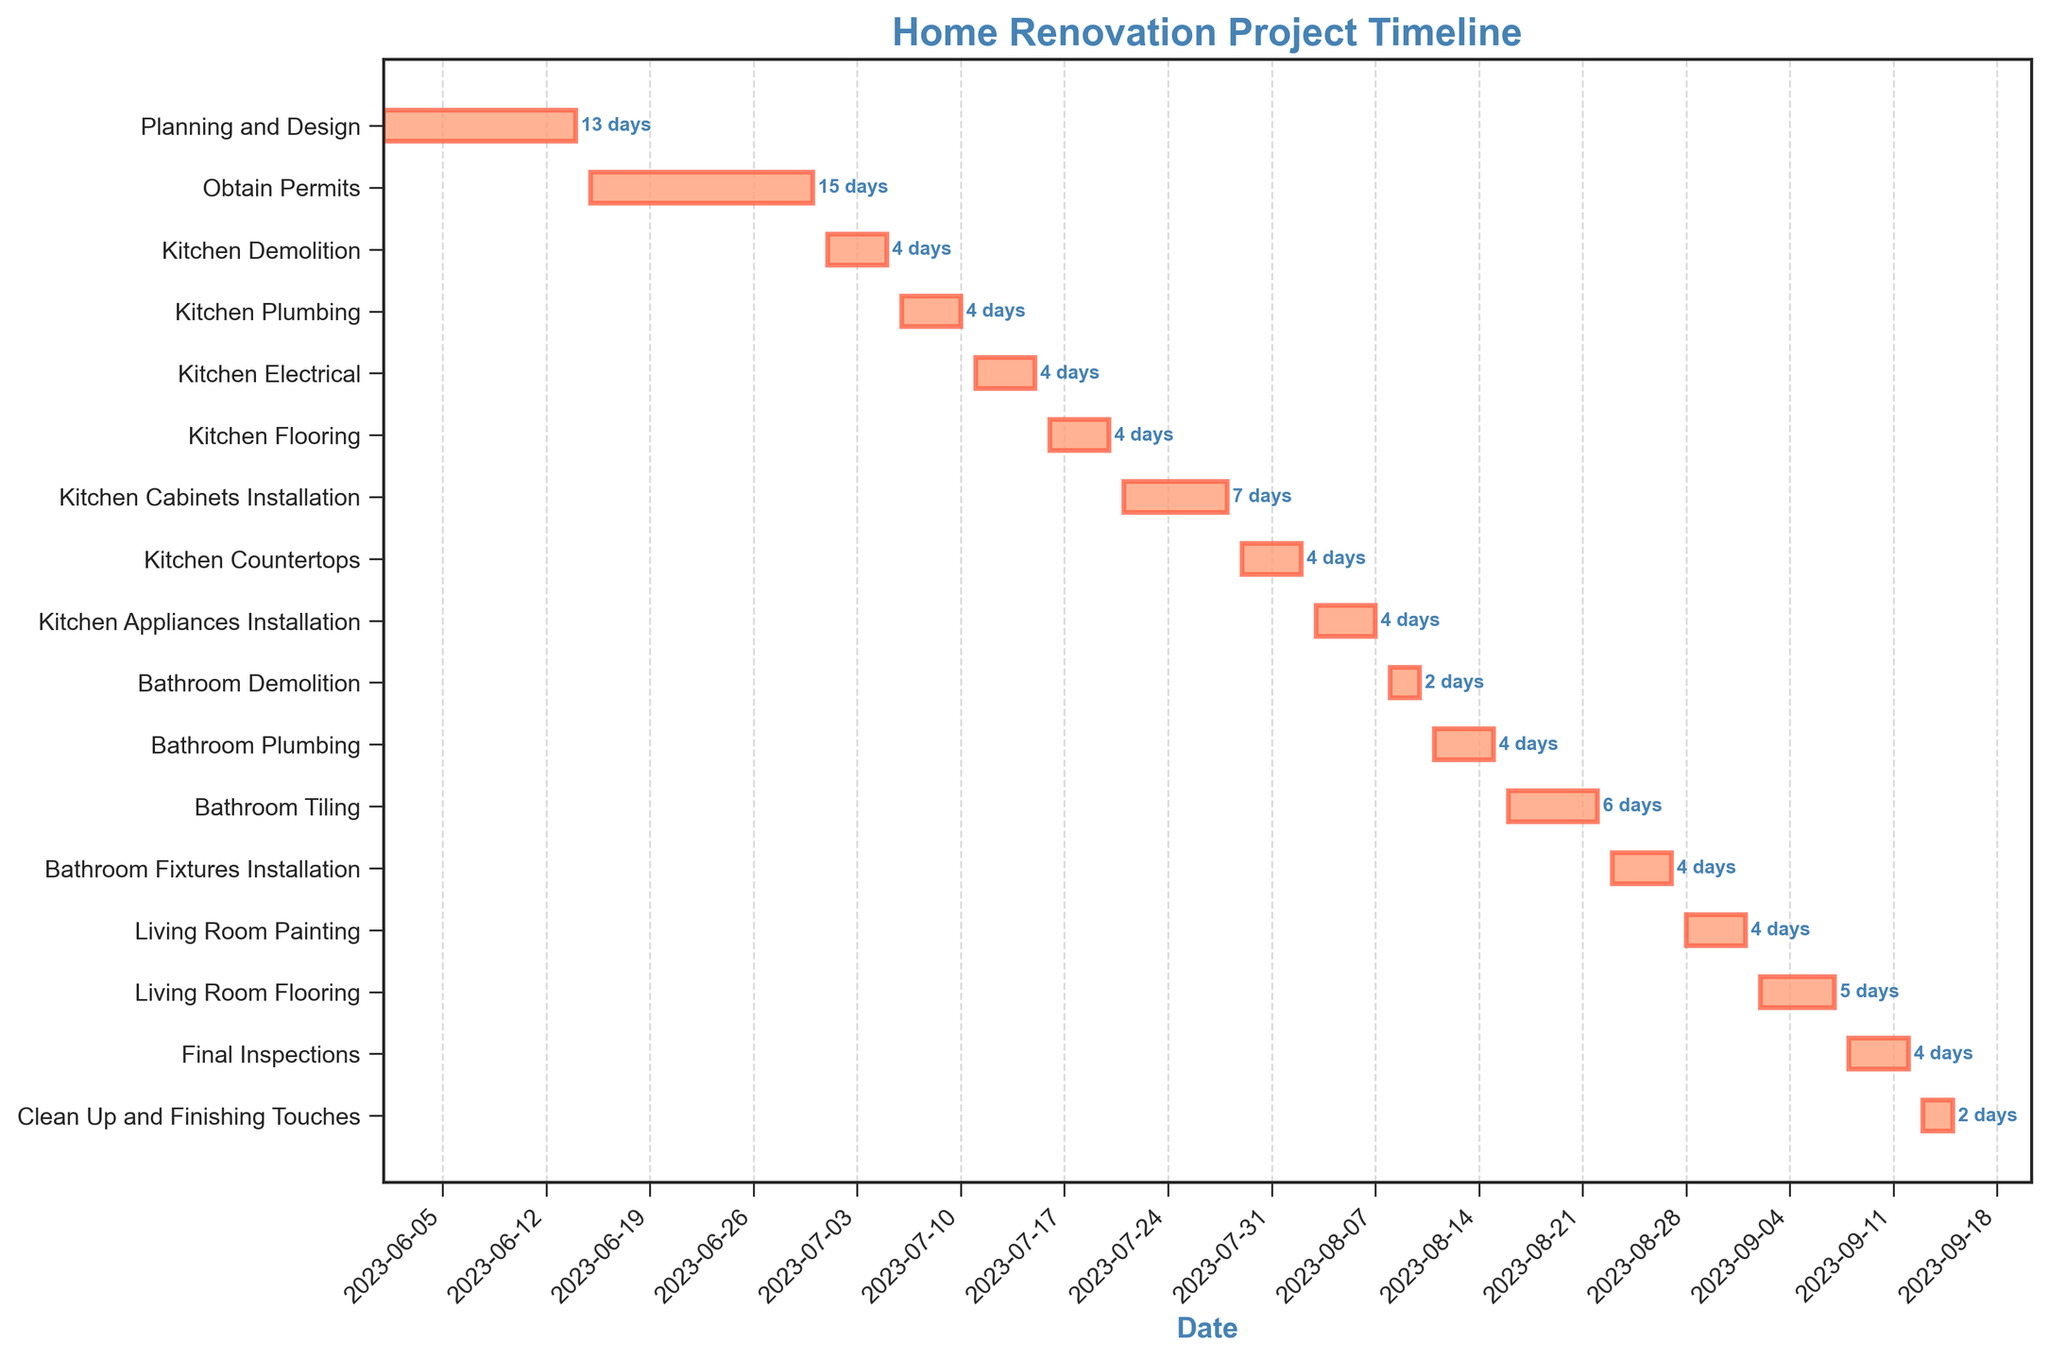What is the title of the figure? The title of the figure is displayed at the top and reads "Home Renovation Project Timeline."
Answer: Home Renovation Project Timeline When does the "Kitchen Plumbing" task start and end? The "Kitchen Plumbing" task starts on July 6, 2023, and ends on July 10, 2023, as indicated by the horizontal bar's start and end points on the y-axis.
Answer: July 6, 2023, to July 10, 2023 Which task takes the longest time to complete, and how many days does it take? By examining the lengths of all the horizontal bars, the "Bathroom Tiling" task takes the longest to complete, spanning from August 16 to August 22, which is 7 days.
Answer: Bathroom Tiling, 7 days How many tasks are scheduled to occur during August? By observing the timeline, the tasks are: "Kitchen Appliances Installation," "Bathroom Demolition," "Bathroom Plumbing," "Bathroom Tiling," "Bathroom Fixtures Installation," "Living Room Painting." Therefore, there are 6 tasks occurring in August.
Answer: 6 tasks What two tasks are scheduled back-to-back without any gap in between? The "Kitchen Countertops" and "Kitchen Appliances Installation" tasks are scheduled back-to-back without any gap, from August 2 to August 3, 2023.
Answer: Kitchen Countertops and Kitchen Appliances Installation When is the final inspection scheduled to take place? According to the figure, the "Final Inspections" task is scheduled to start on September 8 and complete on September 12, 2023.
Answer: September 8, 2023, to September 12, 2023 Which task comes immediately after "Kitchen Electrical"? Referring to the order of tasks on the timeline, "Kitchen Flooring" follows immediately after "Kitchen Electrical" ends.
Answer: Kitchen Flooring Calculate the total duration of all kitchen-related tasks combined. Adding up the duration of "Kitchen Demolition" (5 days), "Kitchen Plumbing" (5 days), "Kitchen Electrical" (5 days), "Kitchen Flooring" (5 days), "Kitchen Cabinets Installation" (8 days), "Kitchen Countertops" (5 days), and "Kitchen Appliances Installation" (5 days) totals to 38 days.
Answer: 38 days Compare the concurrent duration of "Bathroom Plumbing" and "Kitchen Appliances Installation." How many days overlap? "Bathroom Plumbing" lasts from August 11-15, while "Kitchen Appliances Installation" lasts from August 3-7. Therefore, they do not overlap in duration.
Answer: 0 days What tasks are scheduled to be completed by the end of July? By the end of July, the tasks completed are "Planning and Design," "Obtain Permits," "Kitchen Demolition," "Kitchen Plumbing," "Kitchen Electrical," "Kitchen Flooring," "Kitchen Cabinets Installation," and "Kitchen Countertops."
Answer: 8 tasks 